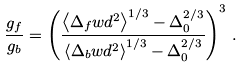<formula> <loc_0><loc_0><loc_500><loc_500>\frac { g _ { f } } { g _ { b } } = \left ( \frac { \left \langle \Delta _ { f } w d ^ { 2 } \right \rangle ^ { 1 / 3 } - \Delta _ { 0 } ^ { 2 / 3 } } { \left \langle \Delta _ { b } w d ^ { 2 } \right \rangle ^ { 1 / 3 } - \Delta _ { 0 } ^ { 2 / 3 } } \right ) ^ { 3 } \, .</formula> 